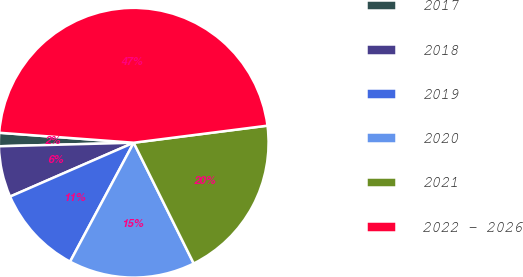<chart> <loc_0><loc_0><loc_500><loc_500><pie_chart><fcel>2017<fcel>2018<fcel>2019<fcel>2020<fcel>2021<fcel>2022 - 2026<nl><fcel>1.6%<fcel>6.12%<fcel>10.64%<fcel>15.16%<fcel>19.68%<fcel>46.8%<nl></chart> 